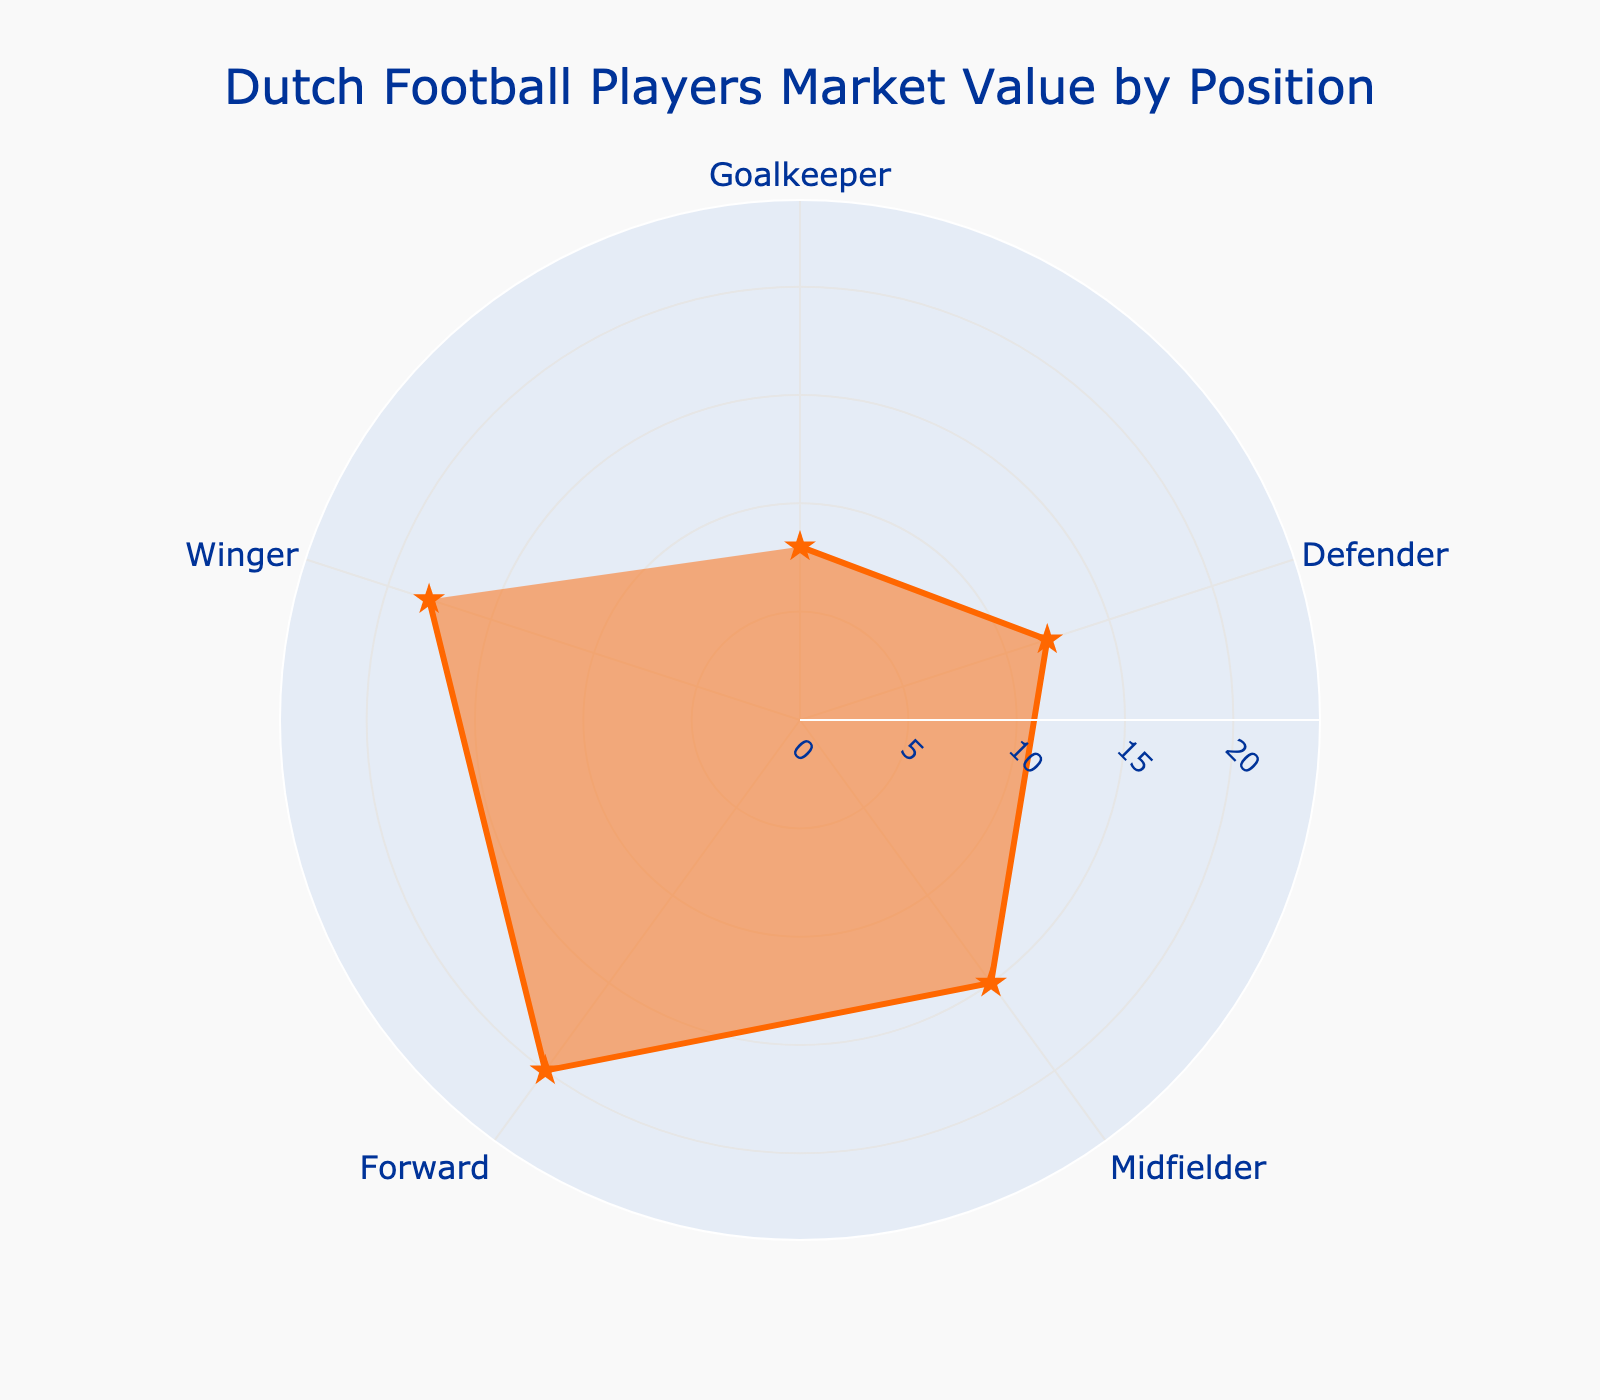What's the title of the chart? The title appears at the top of the chart and usually gives a brief description of what the figure is about. Here, it states "Dutch Football Players Market Value by Position."
Answer: Dutch Football Players Market Value by Position How many positions are shown in the figure? To determine the number of positions, count the different labels along the angular axis.
Answer: 5 Which position has the highest average market value? To find this, look at the position with the largest radial distance. Here, the "Forward" position has the highest value.
Answer: Forward What is the average market value of Goalkeepers and Defenders combined? Add the average market values of Goalkeepers (€8 million) and Defenders (€12 million).
Answer: €20 million Do Midfielders have a higher average market value than Defenders? Compare the radial distance values of "Midfielder" and "Defender." Midfielders are further out at €15 million compared to Defenders at €12 million.
Answer: Yes Which positions have an average market value greater than €10 million? Look for positions whose radial distance values are above €10 million. These are Defenders, Midfielders, Wingers, and Forwards.
Answer: Defender, Midfielder, Forward, Winger What's the difference between the highest and lowest average market values? Subtract the lowest value (€8 million for Goalkeeper) from the highest (€20 million for Forward).
Answer: €12 million Are the average market values for Wingers closer to that of Midfielders or Forwards? Compare the values: Wingers (€18 million), Midfielders (€15 million), and Forwards (€20 million). Wingers are closer to Forwards.
Answer: Forwards What's the approximate range of the radial axis? The radial axis appears to span from 0 to a value just beyond the highest market value, about €24 million. This indicates a range of 0 to around €24 million.
Answer: 0 to €24 million What is the average market value for Midfielders compared to Goalkeepers? Compare the radial distance values, Midfielders (€15 million) and Goalkeepers (€8 million). Midfielders have almost double the value of Goalkeepers.
Answer: Midfielders are almost double 